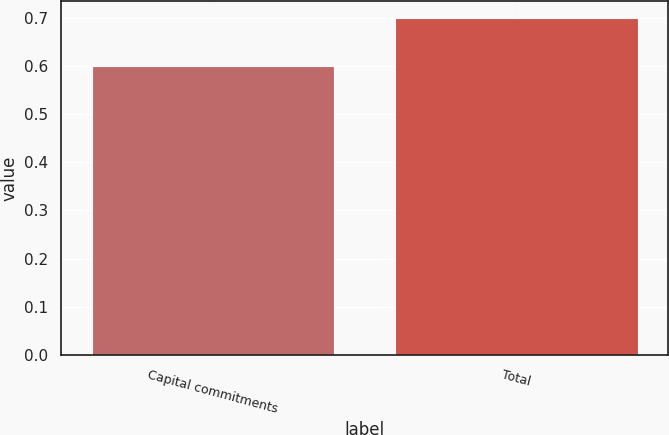<chart> <loc_0><loc_0><loc_500><loc_500><bar_chart><fcel>Capital commitments<fcel>Total<nl><fcel>0.6<fcel>0.7<nl></chart> 